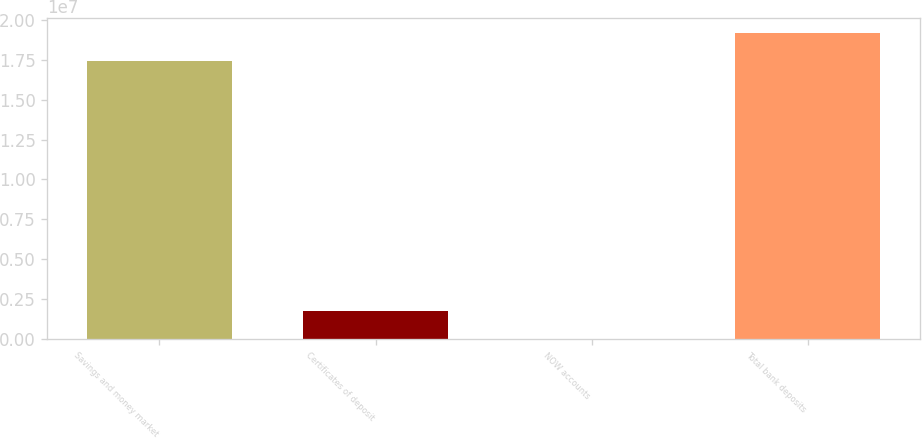Convert chart to OTSL. <chart><loc_0><loc_0><loc_500><loc_500><bar_chart><fcel>Savings and money market<fcel>Certificates of deposit<fcel>NOW accounts<fcel>Total bank deposits<nl><fcel>1.73911e+07<fcel>1.77791e+06<fcel>5197<fcel>1.91638e+07<nl></chart> 